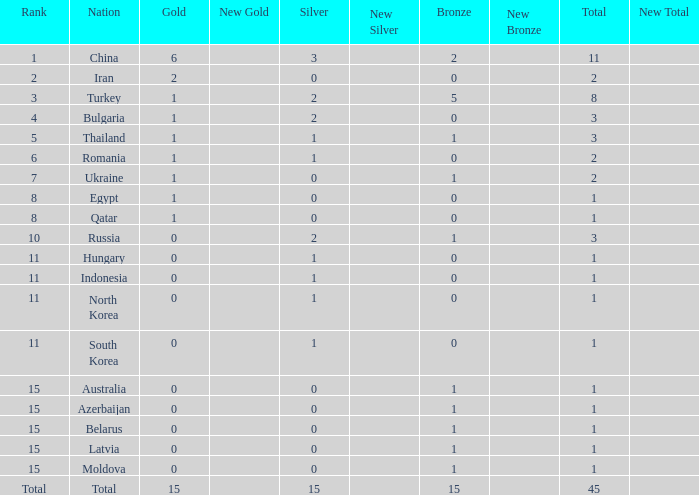Wha is the average number of bronze of hungary, which has less than 1 silver? None. 